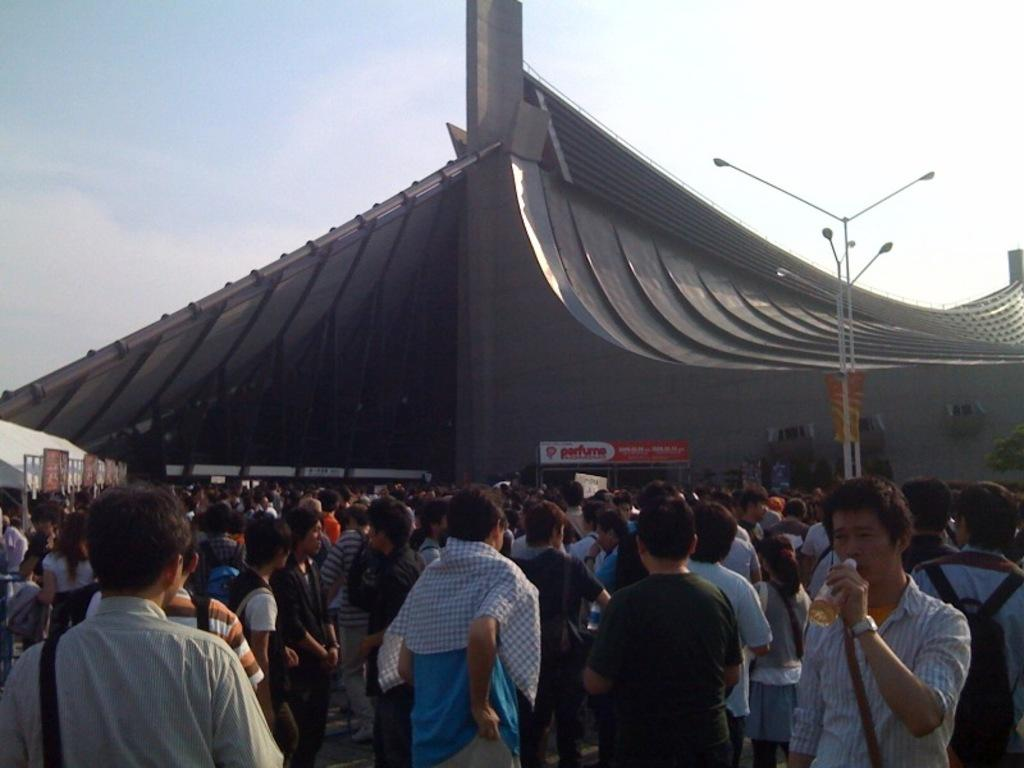What is happening in the center of the image? There are many people standing in the center of the image. What can be seen in the background of the image? There is a building in the background of the image. What type of lighting is present in the image? There are street lights in the image. How many ants can be seen crawling on the shirt of the person in the image? There are no ants or shirts visible in the image. 